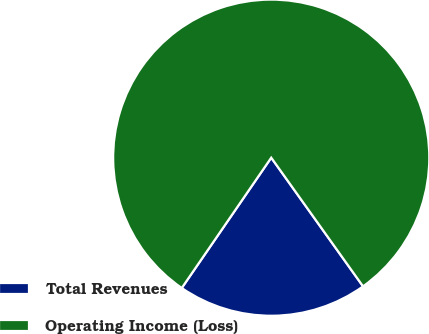Convert chart. <chart><loc_0><loc_0><loc_500><loc_500><pie_chart><fcel>Total Revenues<fcel>Operating Income (Loss)<nl><fcel>19.44%<fcel>80.56%<nl></chart> 